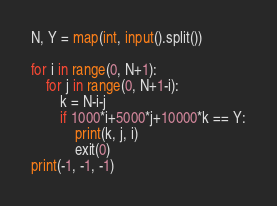Convert code to text. <code><loc_0><loc_0><loc_500><loc_500><_Python_>N, Y = map(int, input().split())

for i in range(0, N+1):
    for j in range(0, N+1-i):
        k = N-i-j
        if 1000*i+5000*j+10000*k == Y:
            print(k, j, i)
            exit(0)
print(-1, -1, -1)
</code> 